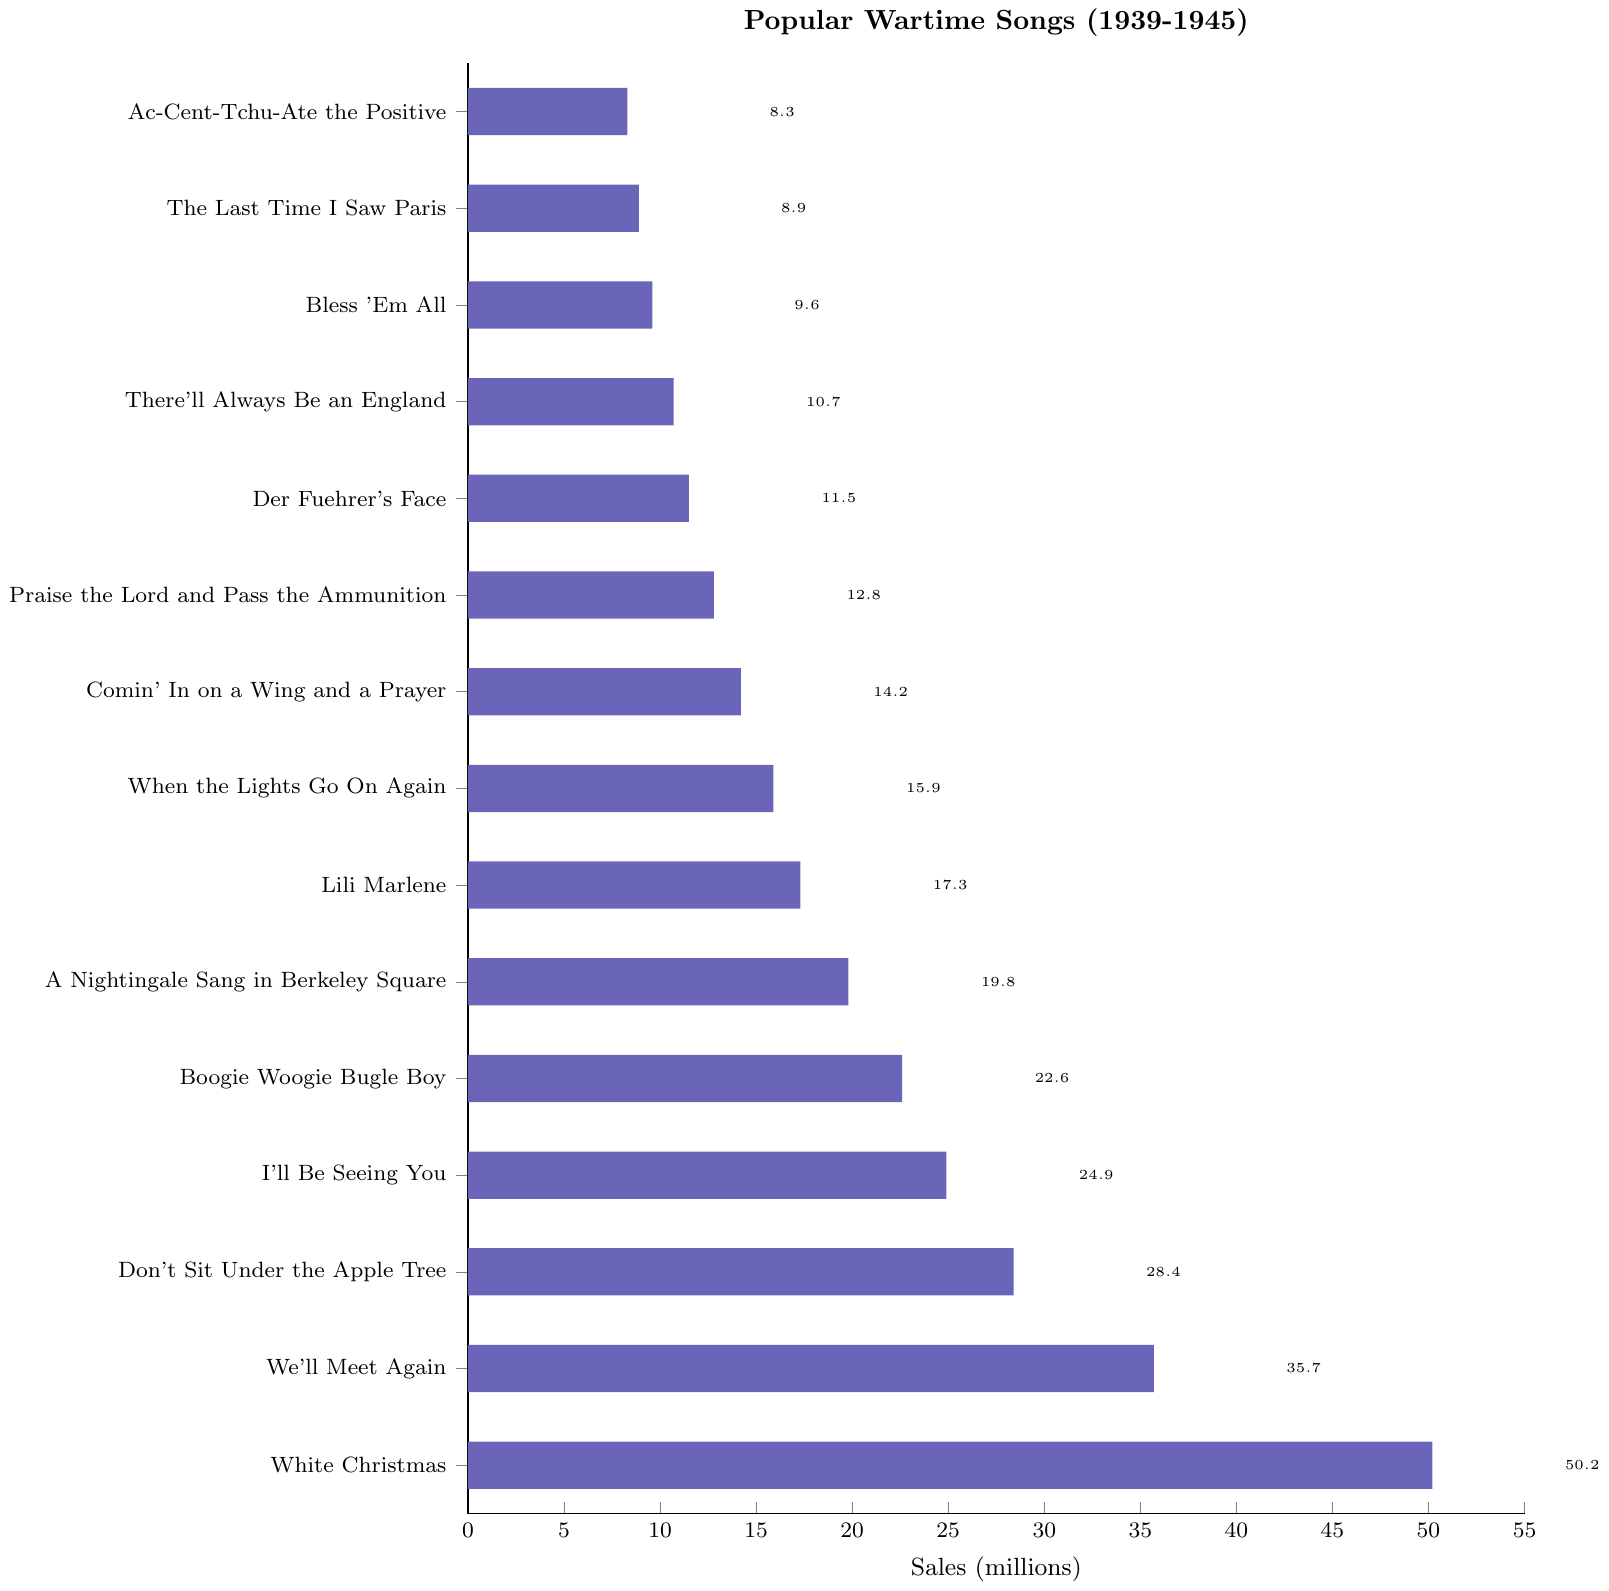Which song has the highest number of sales? The song with the highest number of sales can be identified by looking at the bar with the greatest length. "White Christmas" has the highest bar, indicating it has the most sales.
Answer: White Christmas Which song has more sales, "I'll Be Seeing You" or "A Nightingale Sang in Berkeley Square"? Compare the lengths of the bars for "I'll Be Seeing You" and "A Nightingale Sang in Berkeley Square". "I'll Be Seeing You" has a longer bar at 24.9 million sales compared to "A Nightingale Sang in Berkeley Square" with 19.8 million.
Answer: I'll Be Seeing You What is the total sales of "Boogie Woogie Bugle Boy" and "Lili Marlene"? Sum the sales of "Boogie Woogie Bugle Boy" and "Lili Marlene". "Boogie Woogie Bugle Boy" has 22.6 million sales and "Lili Marlene" has 17.3 million sales. So, 22.6 + 17.3 = 39.9 million.
Answer: 39.9 million How many songs have sales greater than 20 million? Count all the bars where the sales value is more than 20 million. The songs are: "White Christmas", "We'll Meet Again", "Don't Sit Under the Apple Tree", "I'll Be Seeing You", and "Boogie Woogie Bugle Boy". This gives us 5 songs.
Answer: 5 What is the difference in sales between "We'll Meet Again" and "Don't Sit Under the Apple Tree"? Subtract the sales of "Don't Sit Under the Apple Tree" from "We'll Meet Again": "We'll Meet Again" has 35.7 million sales and "Don't Sit Under the Apple Tree" has 28.4 million sales. So, 35.7 - 28.4 = 7.3 million.
Answer: 7.3 million Which song has the lowest number of sales? The song with the lowest number of sales can be found by identifying the shortest bar. "Ac-Cent-Tchu-Ate the Positive" has the shortest bar with 8.3 million sales.
Answer: Ac-Cent-Tchu-Ate the Positive What is the average sales of the top 3 songs? Find the sales of the top 3 songs: "White Christmas" (50.2), "We'll Meet Again" (35.7), and "Don't Sit Under the Apple Tree" (28.4). Sum these values and divide by 3: (50.2 + 35.7 + 28.4) / 3 = 38.1 million.
Answer: 38.1 million Which songs have sales between 10 million and 20 million? Identify the songs with sales between 10 million and 20 million by looking at the bars within this range. They are: "A Nightingale Sang in Berkeley Square" (19.8), "Lili Marlene" (17.3), "When the Lights Go On Again" (15.9), "Comin' In on a Wing and a Prayer" (14.2), "Praise the Lord and Pass the Ammunition" (12.8), "Der Fuehrer's Face" (11.5), and "There'll Always Be an England" (10.7).
Answer: A Nightingale Sang in Berkeley Square, Lili Marlene, When the Lights Go On Again, Comin' In on a Wing and a Prayer, Praise the Lord and Pass the Ammunition, Der Fuehrer's Face, There'll Always Be an England What is the combined sales of "Der Fuehrer's Face" and "Bless 'Em All"? Sum the sales of "Der Fuehrer's Face" and "Bless 'Em All". "Der Fuehrer's Face" has 11.5 million sales and "Bless 'Em All" has 9.6 million sales. So, 11.5 + 9.6 = 21.1 million.
Answer: 21.1 million How much more sales does "Don't Sit Under the Apple Tree" have compared to "Comin' In on a Wing and a Prayer"? Subtract the sales of "Comin' In on a Wing and a Prayer" from "Don't Sit Under the Apple Tree": "Don't Sit Under the Apple Tree" has 28.4 million sales and "Comin' In on a Wing and a Prayer" has 14.2 million sales. So, 28.4 - 14.2 = 14.2 million.
Answer: 14.2 million 